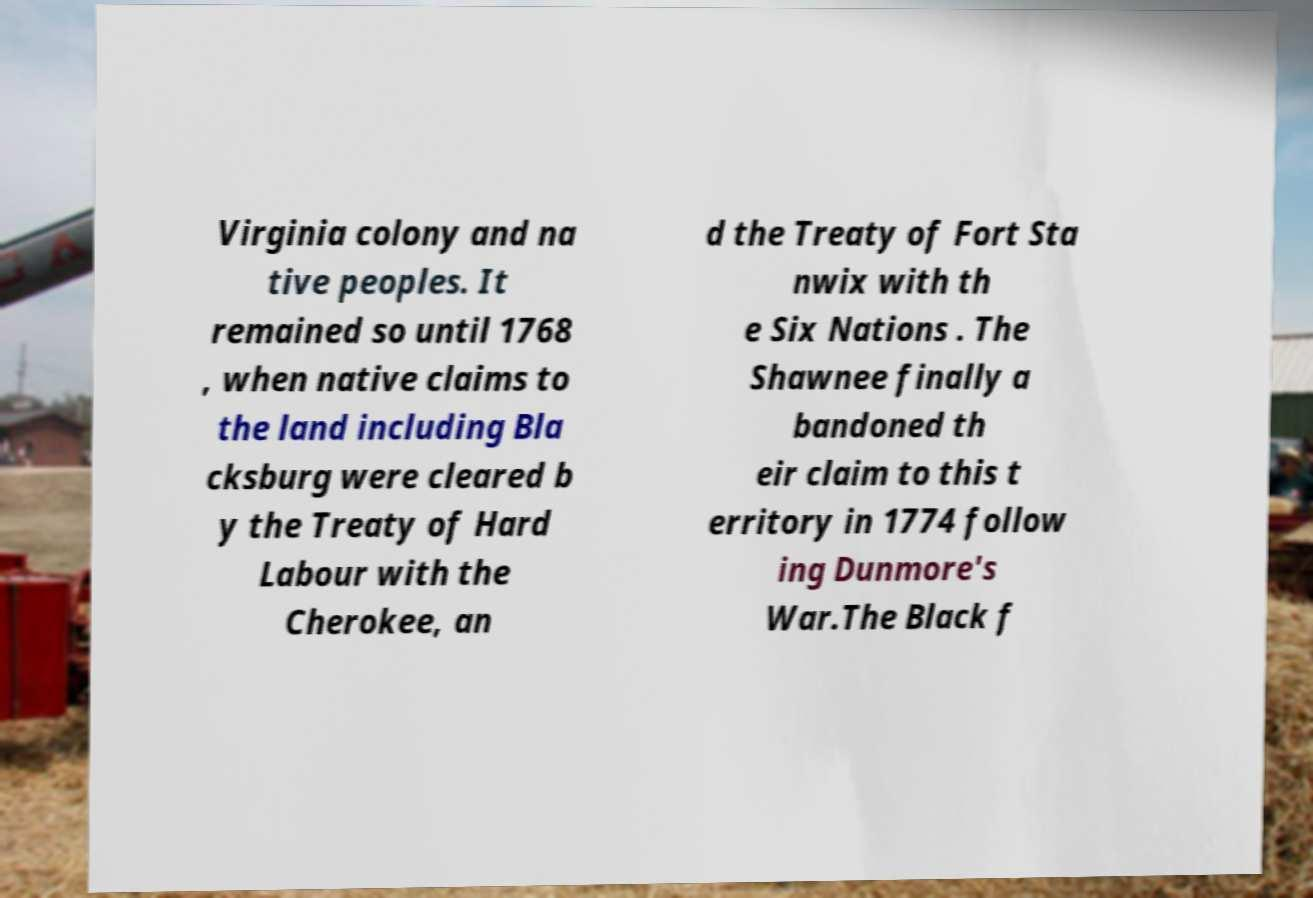Could you assist in decoding the text presented in this image and type it out clearly? Virginia colony and na tive peoples. It remained so until 1768 , when native claims to the land including Bla cksburg were cleared b y the Treaty of Hard Labour with the Cherokee, an d the Treaty of Fort Sta nwix with th e Six Nations . The Shawnee finally a bandoned th eir claim to this t erritory in 1774 follow ing Dunmore's War.The Black f 